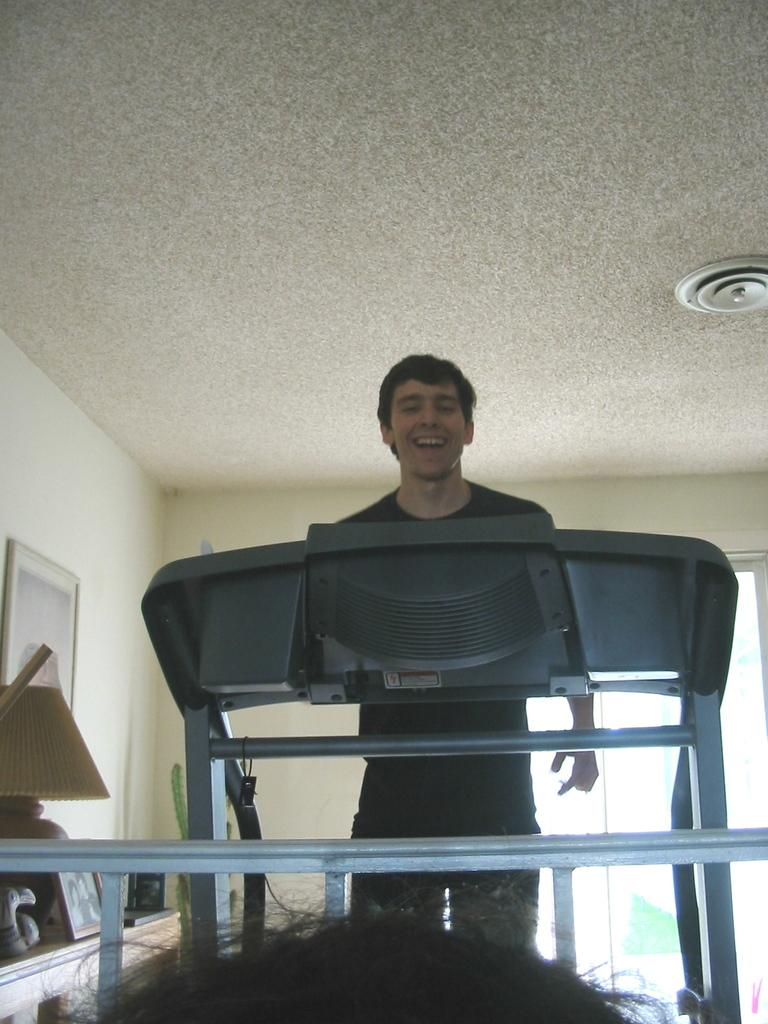Who or what is present in the image? There is a person in the image. What piece of furniture can be seen in the image? There is a table in the image. What is placed on the table? There is a picture and a lamp on the table, along with other objects. Where is the picture located in the image? The picture is on the wall in the image. How many feet are visible in the image? There is no mention of feet or any body parts in the image, so it is impossible to determine the number of feet visible. 